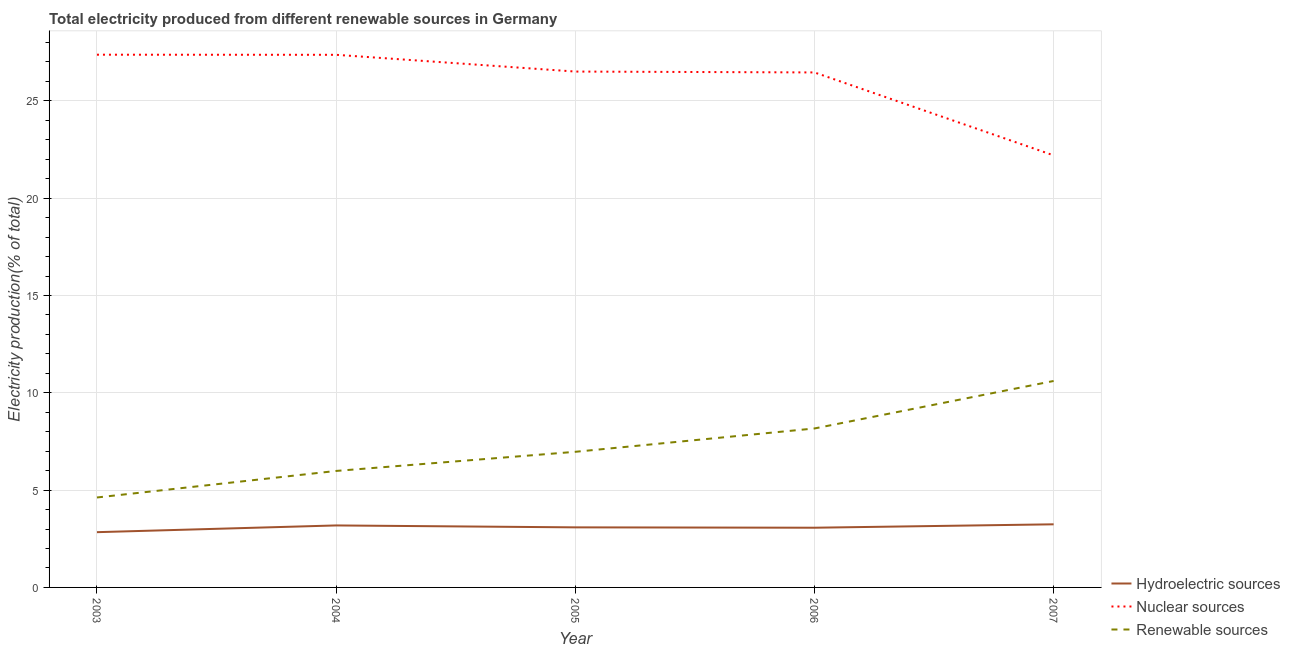How many different coloured lines are there?
Offer a terse response. 3. What is the percentage of electricity produced by renewable sources in 2003?
Provide a short and direct response. 4.62. Across all years, what is the maximum percentage of electricity produced by hydroelectric sources?
Offer a terse response. 3.24. Across all years, what is the minimum percentage of electricity produced by renewable sources?
Give a very brief answer. 4.62. In which year was the percentage of electricity produced by hydroelectric sources maximum?
Offer a terse response. 2007. In which year was the percentage of electricity produced by renewable sources minimum?
Give a very brief answer. 2003. What is the total percentage of electricity produced by hydroelectric sources in the graph?
Ensure brevity in your answer.  15.42. What is the difference between the percentage of electricity produced by renewable sources in 2005 and that in 2007?
Ensure brevity in your answer.  -3.64. What is the difference between the percentage of electricity produced by nuclear sources in 2006 and the percentage of electricity produced by hydroelectric sources in 2004?
Ensure brevity in your answer.  23.28. What is the average percentage of electricity produced by hydroelectric sources per year?
Make the answer very short. 3.08. In the year 2005, what is the difference between the percentage of electricity produced by nuclear sources and percentage of electricity produced by hydroelectric sources?
Your answer should be very brief. 23.42. What is the ratio of the percentage of electricity produced by nuclear sources in 2005 to that in 2006?
Provide a succinct answer. 1. Is the difference between the percentage of electricity produced by nuclear sources in 2003 and 2005 greater than the difference between the percentage of electricity produced by renewable sources in 2003 and 2005?
Provide a succinct answer. Yes. What is the difference between the highest and the second highest percentage of electricity produced by hydroelectric sources?
Keep it short and to the point. 0.06. What is the difference between the highest and the lowest percentage of electricity produced by renewable sources?
Offer a terse response. 5.99. Is the sum of the percentage of electricity produced by hydroelectric sources in 2005 and 2006 greater than the maximum percentage of electricity produced by nuclear sources across all years?
Your answer should be compact. No. Is it the case that in every year, the sum of the percentage of electricity produced by hydroelectric sources and percentage of electricity produced by nuclear sources is greater than the percentage of electricity produced by renewable sources?
Provide a short and direct response. Yes. Does the percentage of electricity produced by renewable sources monotonically increase over the years?
Keep it short and to the point. Yes. Is the percentage of electricity produced by hydroelectric sources strictly greater than the percentage of electricity produced by nuclear sources over the years?
Provide a succinct answer. No. How many lines are there?
Keep it short and to the point. 3. How many years are there in the graph?
Make the answer very short. 5. Does the graph contain any zero values?
Offer a very short reply. No. How many legend labels are there?
Provide a succinct answer. 3. What is the title of the graph?
Give a very brief answer. Total electricity produced from different renewable sources in Germany. What is the label or title of the Y-axis?
Offer a very short reply. Electricity production(% of total). What is the Electricity production(% of total) in Hydroelectric sources in 2003?
Your response must be concise. 2.84. What is the Electricity production(% of total) of Nuclear sources in 2003?
Your answer should be compact. 27.37. What is the Electricity production(% of total) in Renewable sources in 2003?
Your response must be concise. 4.62. What is the Electricity production(% of total) of Hydroelectric sources in 2004?
Ensure brevity in your answer.  3.19. What is the Electricity production(% of total) in Nuclear sources in 2004?
Your answer should be very brief. 27.37. What is the Electricity production(% of total) in Renewable sources in 2004?
Ensure brevity in your answer.  5.99. What is the Electricity production(% of total) in Hydroelectric sources in 2005?
Keep it short and to the point. 3.09. What is the Electricity production(% of total) in Nuclear sources in 2005?
Ensure brevity in your answer.  26.51. What is the Electricity production(% of total) in Renewable sources in 2005?
Your answer should be very brief. 6.97. What is the Electricity production(% of total) in Hydroelectric sources in 2006?
Your answer should be compact. 3.07. What is the Electricity production(% of total) in Nuclear sources in 2006?
Make the answer very short. 26.46. What is the Electricity production(% of total) of Renewable sources in 2006?
Provide a short and direct response. 8.17. What is the Electricity production(% of total) of Hydroelectric sources in 2007?
Your answer should be very brief. 3.24. What is the Electricity production(% of total) in Nuclear sources in 2007?
Offer a terse response. 22.2. What is the Electricity production(% of total) of Renewable sources in 2007?
Your answer should be very brief. 10.61. Across all years, what is the maximum Electricity production(% of total) in Hydroelectric sources?
Offer a terse response. 3.24. Across all years, what is the maximum Electricity production(% of total) in Nuclear sources?
Provide a short and direct response. 27.37. Across all years, what is the maximum Electricity production(% of total) in Renewable sources?
Offer a terse response. 10.61. Across all years, what is the minimum Electricity production(% of total) of Hydroelectric sources?
Give a very brief answer. 2.84. Across all years, what is the minimum Electricity production(% of total) of Nuclear sources?
Provide a succinct answer. 22.2. Across all years, what is the minimum Electricity production(% of total) in Renewable sources?
Your answer should be very brief. 4.62. What is the total Electricity production(% of total) of Hydroelectric sources in the graph?
Offer a terse response. 15.42. What is the total Electricity production(% of total) of Nuclear sources in the graph?
Offer a very short reply. 129.91. What is the total Electricity production(% of total) of Renewable sources in the graph?
Provide a succinct answer. 36.35. What is the difference between the Electricity production(% of total) of Hydroelectric sources in 2003 and that in 2004?
Ensure brevity in your answer.  -0.35. What is the difference between the Electricity production(% of total) in Nuclear sources in 2003 and that in 2004?
Your answer should be compact. 0.01. What is the difference between the Electricity production(% of total) in Renewable sources in 2003 and that in 2004?
Provide a succinct answer. -1.36. What is the difference between the Electricity production(% of total) of Hydroelectric sources in 2003 and that in 2005?
Provide a short and direct response. -0.25. What is the difference between the Electricity production(% of total) in Nuclear sources in 2003 and that in 2005?
Your response must be concise. 0.87. What is the difference between the Electricity production(% of total) in Renewable sources in 2003 and that in 2005?
Offer a terse response. -2.35. What is the difference between the Electricity production(% of total) of Hydroelectric sources in 2003 and that in 2006?
Provide a succinct answer. -0.23. What is the difference between the Electricity production(% of total) in Nuclear sources in 2003 and that in 2006?
Ensure brevity in your answer.  0.91. What is the difference between the Electricity production(% of total) in Renewable sources in 2003 and that in 2006?
Keep it short and to the point. -3.55. What is the difference between the Electricity production(% of total) in Hydroelectric sources in 2003 and that in 2007?
Make the answer very short. -0.4. What is the difference between the Electricity production(% of total) in Nuclear sources in 2003 and that in 2007?
Your answer should be very brief. 5.17. What is the difference between the Electricity production(% of total) of Renewable sources in 2003 and that in 2007?
Your answer should be very brief. -5.99. What is the difference between the Electricity production(% of total) of Hydroelectric sources in 2004 and that in 2005?
Your answer should be very brief. 0.1. What is the difference between the Electricity production(% of total) in Nuclear sources in 2004 and that in 2005?
Offer a terse response. 0.86. What is the difference between the Electricity production(% of total) in Renewable sources in 2004 and that in 2005?
Your response must be concise. -0.98. What is the difference between the Electricity production(% of total) in Hydroelectric sources in 2004 and that in 2006?
Your answer should be very brief. 0.12. What is the difference between the Electricity production(% of total) in Nuclear sources in 2004 and that in 2006?
Your answer should be compact. 0.91. What is the difference between the Electricity production(% of total) of Renewable sources in 2004 and that in 2006?
Give a very brief answer. -2.18. What is the difference between the Electricity production(% of total) in Hydroelectric sources in 2004 and that in 2007?
Provide a succinct answer. -0.06. What is the difference between the Electricity production(% of total) of Nuclear sources in 2004 and that in 2007?
Ensure brevity in your answer.  5.17. What is the difference between the Electricity production(% of total) in Renewable sources in 2004 and that in 2007?
Keep it short and to the point. -4.62. What is the difference between the Electricity production(% of total) of Hydroelectric sources in 2005 and that in 2006?
Offer a very short reply. 0.02. What is the difference between the Electricity production(% of total) in Nuclear sources in 2005 and that in 2006?
Your answer should be compact. 0.04. What is the difference between the Electricity production(% of total) of Renewable sources in 2005 and that in 2006?
Your response must be concise. -1.2. What is the difference between the Electricity production(% of total) in Hydroelectric sources in 2005 and that in 2007?
Make the answer very short. -0.16. What is the difference between the Electricity production(% of total) in Nuclear sources in 2005 and that in 2007?
Offer a very short reply. 4.31. What is the difference between the Electricity production(% of total) of Renewable sources in 2005 and that in 2007?
Keep it short and to the point. -3.64. What is the difference between the Electricity production(% of total) in Hydroelectric sources in 2006 and that in 2007?
Ensure brevity in your answer.  -0.17. What is the difference between the Electricity production(% of total) of Nuclear sources in 2006 and that in 2007?
Make the answer very short. 4.26. What is the difference between the Electricity production(% of total) in Renewable sources in 2006 and that in 2007?
Your answer should be compact. -2.44. What is the difference between the Electricity production(% of total) of Hydroelectric sources in 2003 and the Electricity production(% of total) of Nuclear sources in 2004?
Your answer should be compact. -24.53. What is the difference between the Electricity production(% of total) of Hydroelectric sources in 2003 and the Electricity production(% of total) of Renewable sources in 2004?
Provide a succinct answer. -3.15. What is the difference between the Electricity production(% of total) of Nuclear sources in 2003 and the Electricity production(% of total) of Renewable sources in 2004?
Provide a short and direct response. 21.39. What is the difference between the Electricity production(% of total) of Hydroelectric sources in 2003 and the Electricity production(% of total) of Nuclear sources in 2005?
Your response must be concise. -23.67. What is the difference between the Electricity production(% of total) of Hydroelectric sources in 2003 and the Electricity production(% of total) of Renewable sources in 2005?
Provide a short and direct response. -4.13. What is the difference between the Electricity production(% of total) of Nuclear sources in 2003 and the Electricity production(% of total) of Renewable sources in 2005?
Offer a very short reply. 20.4. What is the difference between the Electricity production(% of total) of Hydroelectric sources in 2003 and the Electricity production(% of total) of Nuclear sources in 2006?
Your answer should be very brief. -23.62. What is the difference between the Electricity production(% of total) in Hydroelectric sources in 2003 and the Electricity production(% of total) in Renewable sources in 2006?
Provide a succinct answer. -5.33. What is the difference between the Electricity production(% of total) of Nuclear sources in 2003 and the Electricity production(% of total) of Renewable sources in 2006?
Provide a short and direct response. 19.21. What is the difference between the Electricity production(% of total) in Hydroelectric sources in 2003 and the Electricity production(% of total) in Nuclear sources in 2007?
Keep it short and to the point. -19.36. What is the difference between the Electricity production(% of total) of Hydroelectric sources in 2003 and the Electricity production(% of total) of Renewable sources in 2007?
Your answer should be very brief. -7.77. What is the difference between the Electricity production(% of total) in Nuclear sources in 2003 and the Electricity production(% of total) in Renewable sources in 2007?
Your response must be concise. 16.77. What is the difference between the Electricity production(% of total) in Hydroelectric sources in 2004 and the Electricity production(% of total) in Nuclear sources in 2005?
Ensure brevity in your answer.  -23.32. What is the difference between the Electricity production(% of total) of Hydroelectric sources in 2004 and the Electricity production(% of total) of Renewable sources in 2005?
Offer a terse response. -3.78. What is the difference between the Electricity production(% of total) in Nuclear sources in 2004 and the Electricity production(% of total) in Renewable sources in 2005?
Provide a succinct answer. 20.4. What is the difference between the Electricity production(% of total) of Hydroelectric sources in 2004 and the Electricity production(% of total) of Nuclear sources in 2006?
Offer a very short reply. -23.28. What is the difference between the Electricity production(% of total) of Hydroelectric sources in 2004 and the Electricity production(% of total) of Renewable sources in 2006?
Give a very brief answer. -4.98. What is the difference between the Electricity production(% of total) of Nuclear sources in 2004 and the Electricity production(% of total) of Renewable sources in 2006?
Make the answer very short. 19.2. What is the difference between the Electricity production(% of total) of Hydroelectric sources in 2004 and the Electricity production(% of total) of Nuclear sources in 2007?
Provide a short and direct response. -19.01. What is the difference between the Electricity production(% of total) of Hydroelectric sources in 2004 and the Electricity production(% of total) of Renewable sources in 2007?
Provide a succinct answer. -7.42. What is the difference between the Electricity production(% of total) in Nuclear sources in 2004 and the Electricity production(% of total) in Renewable sources in 2007?
Your answer should be very brief. 16.76. What is the difference between the Electricity production(% of total) in Hydroelectric sources in 2005 and the Electricity production(% of total) in Nuclear sources in 2006?
Your response must be concise. -23.37. What is the difference between the Electricity production(% of total) in Hydroelectric sources in 2005 and the Electricity production(% of total) in Renewable sources in 2006?
Your response must be concise. -5.08. What is the difference between the Electricity production(% of total) of Nuclear sources in 2005 and the Electricity production(% of total) of Renewable sources in 2006?
Give a very brief answer. 18.34. What is the difference between the Electricity production(% of total) in Hydroelectric sources in 2005 and the Electricity production(% of total) in Nuclear sources in 2007?
Offer a terse response. -19.11. What is the difference between the Electricity production(% of total) in Hydroelectric sources in 2005 and the Electricity production(% of total) in Renewable sources in 2007?
Offer a terse response. -7.52. What is the difference between the Electricity production(% of total) of Nuclear sources in 2005 and the Electricity production(% of total) of Renewable sources in 2007?
Keep it short and to the point. 15.9. What is the difference between the Electricity production(% of total) of Hydroelectric sources in 2006 and the Electricity production(% of total) of Nuclear sources in 2007?
Your response must be concise. -19.13. What is the difference between the Electricity production(% of total) of Hydroelectric sources in 2006 and the Electricity production(% of total) of Renewable sources in 2007?
Provide a succinct answer. -7.54. What is the difference between the Electricity production(% of total) of Nuclear sources in 2006 and the Electricity production(% of total) of Renewable sources in 2007?
Keep it short and to the point. 15.85. What is the average Electricity production(% of total) in Hydroelectric sources per year?
Offer a terse response. 3.08. What is the average Electricity production(% of total) in Nuclear sources per year?
Keep it short and to the point. 25.98. What is the average Electricity production(% of total) of Renewable sources per year?
Ensure brevity in your answer.  7.27. In the year 2003, what is the difference between the Electricity production(% of total) of Hydroelectric sources and Electricity production(% of total) of Nuclear sources?
Offer a terse response. -24.53. In the year 2003, what is the difference between the Electricity production(% of total) in Hydroelectric sources and Electricity production(% of total) in Renewable sources?
Your answer should be very brief. -1.78. In the year 2003, what is the difference between the Electricity production(% of total) of Nuclear sources and Electricity production(% of total) of Renewable sources?
Give a very brief answer. 22.75. In the year 2004, what is the difference between the Electricity production(% of total) in Hydroelectric sources and Electricity production(% of total) in Nuclear sources?
Provide a succinct answer. -24.18. In the year 2004, what is the difference between the Electricity production(% of total) of Hydroelectric sources and Electricity production(% of total) of Renewable sources?
Offer a terse response. -2.8. In the year 2004, what is the difference between the Electricity production(% of total) in Nuclear sources and Electricity production(% of total) in Renewable sources?
Offer a terse response. 21.38. In the year 2005, what is the difference between the Electricity production(% of total) of Hydroelectric sources and Electricity production(% of total) of Nuclear sources?
Ensure brevity in your answer.  -23.42. In the year 2005, what is the difference between the Electricity production(% of total) of Hydroelectric sources and Electricity production(% of total) of Renewable sources?
Ensure brevity in your answer.  -3.88. In the year 2005, what is the difference between the Electricity production(% of total) in Nuclear sources and Electricity production(% of total) in Renewable sources?
Offer a terse response. 19.54. In the year 2006, what is the difference between the Electricity production(% of total) in Hydroelectric sources and Electricity production(% of total) in Nuclear sources?
Your answer should be very brief. -23.39. In the year 2006, what is the difference between the Electricity production(% of total) of Hydroelectric sources and Electricity production(% of total) of Renewable sources?
Ensure brevity in your answer.  -5.1. In the year 2006, what is the difference between the Electricity production(% of total) in Nuclear sources and Electricity production(% of total) in Renewable sources?
Offer a very short reply. 18.29. In the year 2007, what is the difference between the Electricity production(% of total) of Hydroelectric sources and Electricity production(% of total) of Nuclear sources?
Offer a terse response. -18.96. In the year 2007, what is the difference between the Electricity production(% of total) of Hydroelectric sources and Electricity production(% of total) of Renewable sources?
Give a very brief answer. -7.36. In the year 2007, what is the difference between the Electricity production(% of total) of Nuclear sources and Electricity production(% of total) of Renewable sources?
Your response must be concise. 11.59. What is the ratio of the Electricity production(% of total) in Hydroelectric sources in 2003 to that in 2004?
Provide a succinct answer. 0.89. What is the ratio of the Electricity production(% of total) in Nuclear sources in 2003 to that in 2004?
Offer a terse response. 1. What is the ratio of the Electricity production(% of total) in Renewable sources in 2003 to that in 2004?
Provide a succinct answer. 0.77. What is the ratio of the Electricity production(% of total) of Hydroelectric sources in 2003 to that in 2005?
Your answer should be very brief. 0.92. What is the ratio of the Electricity production(% of total) in Nuclear sources in 2003 to that in 2005?
Provide a succinct answer. 1.03. What is the ratio of the Electricity production(% of total) of Renewable sources in 2003 to that in 2005?
Offer a terse response. 0.66. What is the ratio of the Electricity production(% of total) in Hydroelectric sources in 2003 to that in 2006?
Your answer should be very brief. 0.93. What is the ratio of the Electricity production(% of total) of Nuclear sources in 2003 to that in 2006?
Offer a terse response. 1.03. What is the ratio of the Electricity production(% of total) of Renewable sources in 2003 to that in 2006?
Ensure brevity in your answer.  0.57. What is the ratio of the Electricity production(% of total) of Hydroelectric sources in 2003 to that in 2007?
Keep it short and to the point. 0.88. What is the ratio of the Electricity production(% of total) of Nuclear sources in 2003 to that in 2007?
Your answer should be very brief. 1.23. What is the ratio of the Electricity production(% of total) of Renewable sources in 2003 to that in 2007?
Your answer should be compact. 0.44. What is the ratio of the Electricity production(% of total) of Hydroelectric sources in 2004 to that in 2005?
Make the answer very short. 1.03. What is the ratio of the Electricity production(% of total) in Nuclear sources in 2004 to that in 2005?
Ensure brevity in your answer.  1.03. What is the ratio of the Electricity production(% of total) of Renewable sources in 2004 to that in 2005?
Make the answer very short. 0.86. What is the ratio of the Electricity production(% of total) in Hydroelectric sources in 2004 to that in 2006?
Your answer should be compact. 1.04. What is the ratio of the Electricity production(% of total) in Nuclear sources in 2004 to that in 2006?
Your answer should be compact. 1.03. What is the ratio of the Electricity production(% of total) of Renewable sources in 2004 to that in 2006?
Provide a succinct answer. 0.73. What is the ratio of the Electricity production(% of total) of Hydroelectric sources in 2004 to that in 2007?
Ensure brevity in your answer.  0.98. What is the ratio of the Electricity production(% of total) of Nuclear sources in 2004 to that in 2007?
Offer a terse response. 1.23. What is the ratio of the Electricity production(% of total) in Renewable sources in 2004 to that in 2007?
Your answer should be very brief. 0.56. What is the ratio of the Electricity production(% of total) of Renewable sources in 2005 to that in 2006?
Your answer should be very brief. 0.85. What is the ratio of the Electricity production(% of total) of Hydroelectric sources in 2005 to that in 2007?
Give a very brief answer. 0.95. What is the ratio of the Electricity production(% of total) in Nuclear sources in 2005 to that in 2007?
Ensure brevity in your answer.  1.19. What is the ratio of the Electricity production(% of total) of Renewable sources in 2005 to that in 2007?
Provide a short and direct response. 0.66. What is the ratio of the Electricity production(% of total) in Hydroelectric sources in 2006 to that in 2007?
Make the answer very short. 0.95. What is the ratio of the Electricity production(% of total) in Nuclear sources in 2006 to that in 2007?
Provide a short and direct response. 1.19. What is the ratio of the Electricity production(% of total) in Renewable sources in 2006 to that in 2007?
Your response must be concise. 0.77. What is the difference between the highest and the second highest Electricity production(% of total) of Hydroelectric sources?
Keep it short and to the point. 0.06. What is the difference between the highest and the second highest Electricity production(% of total) in Nuclear sources?
Your answer should be compact. 0.01. What is the difference between the highest and the second highest Electricity production(% of total) in Renewable sources?
Offer a terse response. 2.44. What is the difference between the highest and the lowest Electricity production(% of total) of Hydroelectric sources?
Keep it short and to the point. 0.4. What is the difference between the highest and the lowest Electricity production(% of total) of Nuclear sources?
Offer a very short reply. 5.17. What is the difference between the highest and the lowest Electricity production(% of total) in Renewable sources?
Provide a succinct answer. 5.99. 